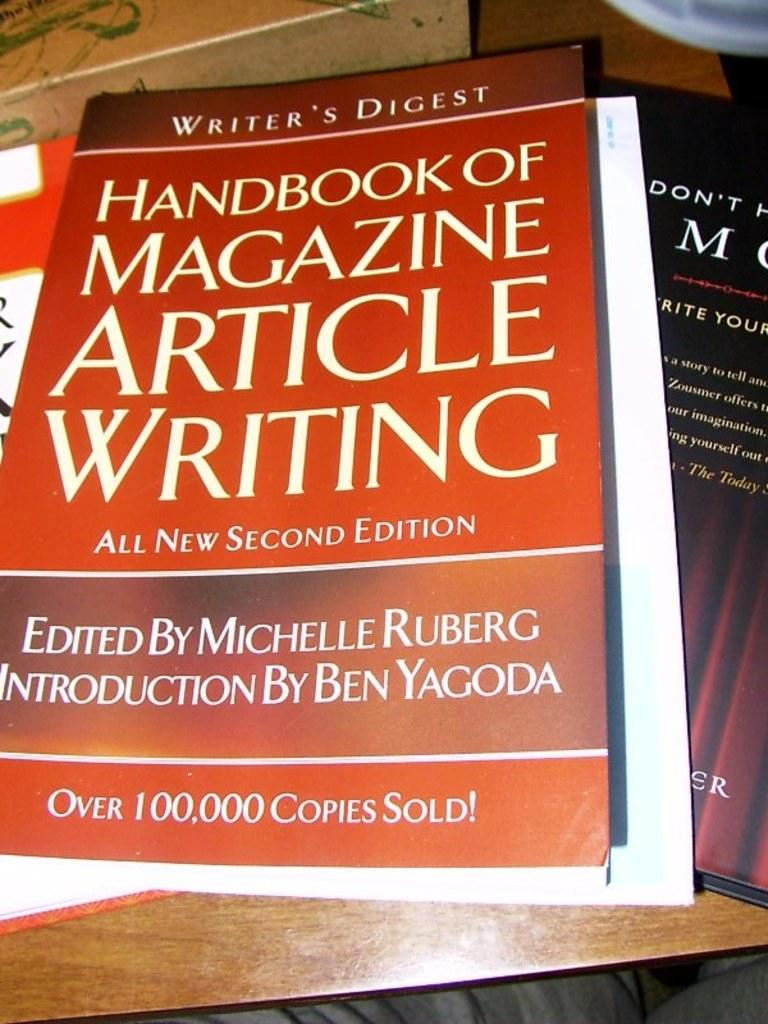<image>
Create a compact narrative representing the image presented. A large book titled HANDBOOK OF MAGAZINE ARTICLE WRITING 